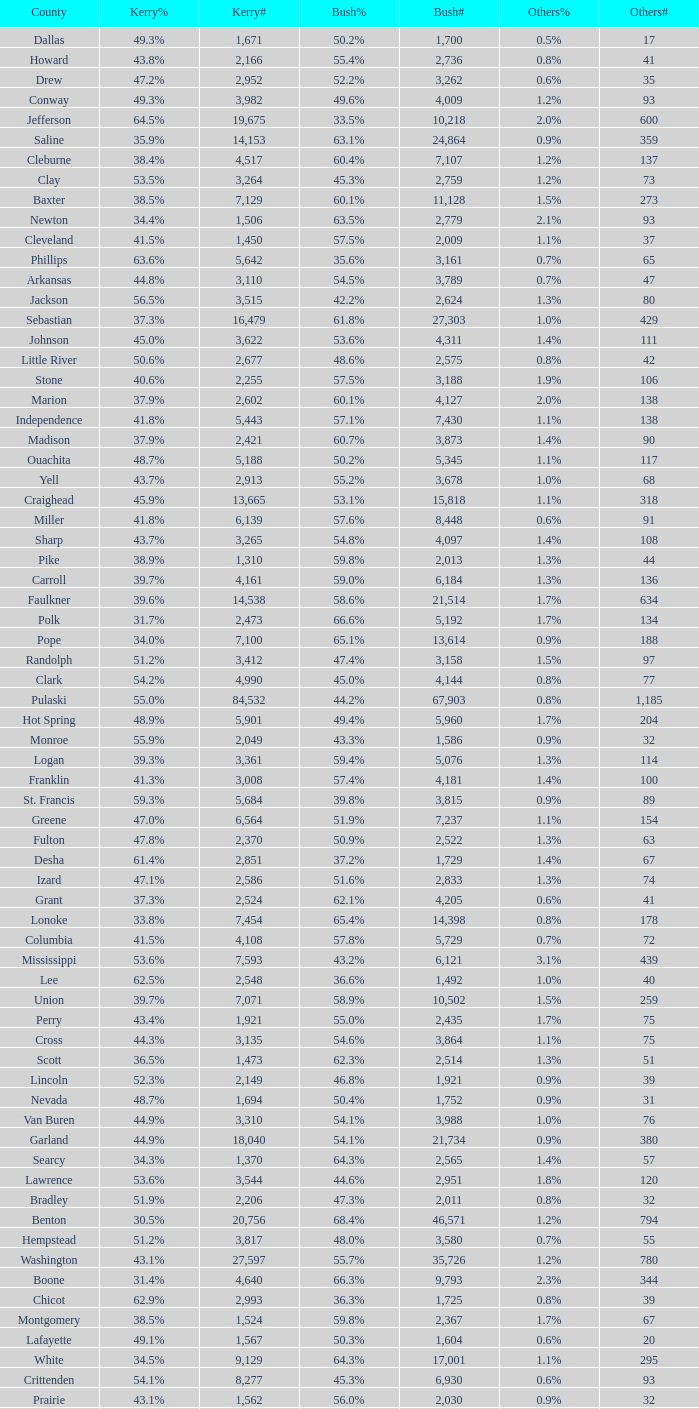What is the lowest Kerry#, when Others# is "106", and when Bush# is less than 3,188? None. 